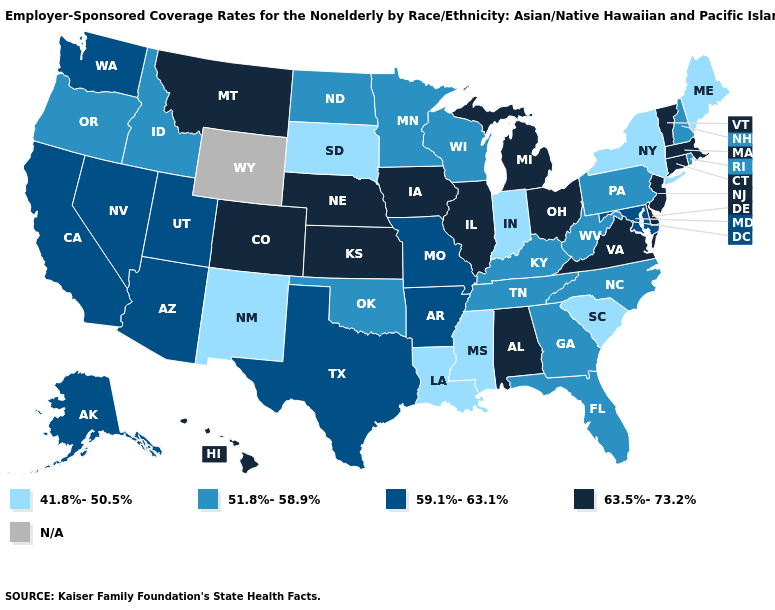What is the value of Mississippi?
Be succinct. 41.8%-50.5%. How many symbols are there in the legend?
Short answer required. 5. What is the value of Hawaii?
Answer briefly. 63.5%-73.2%. Does Rhode Island have the lowest value in the Northeast?
Be succinct. No. What is the lowest value in the South?
Short answer required. 41.8%-50.5%. Name the states that have a value in the range 41.8%-50.5%?
Answer briefly. Indiana, Louisiana, Maine, Mississippi, New Mexico, New York, South Carolina, South Dakota. What is the lowest value in the South?
Write a very short answer. 41.8%-50.5%. Does Delaware have the lowest value in the USA?
Concise answer only. No. What is the value of Georgia?
Short answer required. 51.8%-58.9%. What is the lowest value in the West?
Give a very brief answer. 41.8%-50.5%. What is the value of Minnesota?
Write a very short answer. 51.8%-58.9%. Which states have the lowest value in the MidWest?
Give a very brief answer. Indiana, South Dakota. What is the lowest value in states that border New York?
Short answer required. 51.8%-58.9%. Name the states that have a value in the range 59.1%-63.1%?
Write a very short answer. Alaska, Arizona, Arkansas, California, Maryland, Missouri, Nevada, Texas, Utah, Washington. 